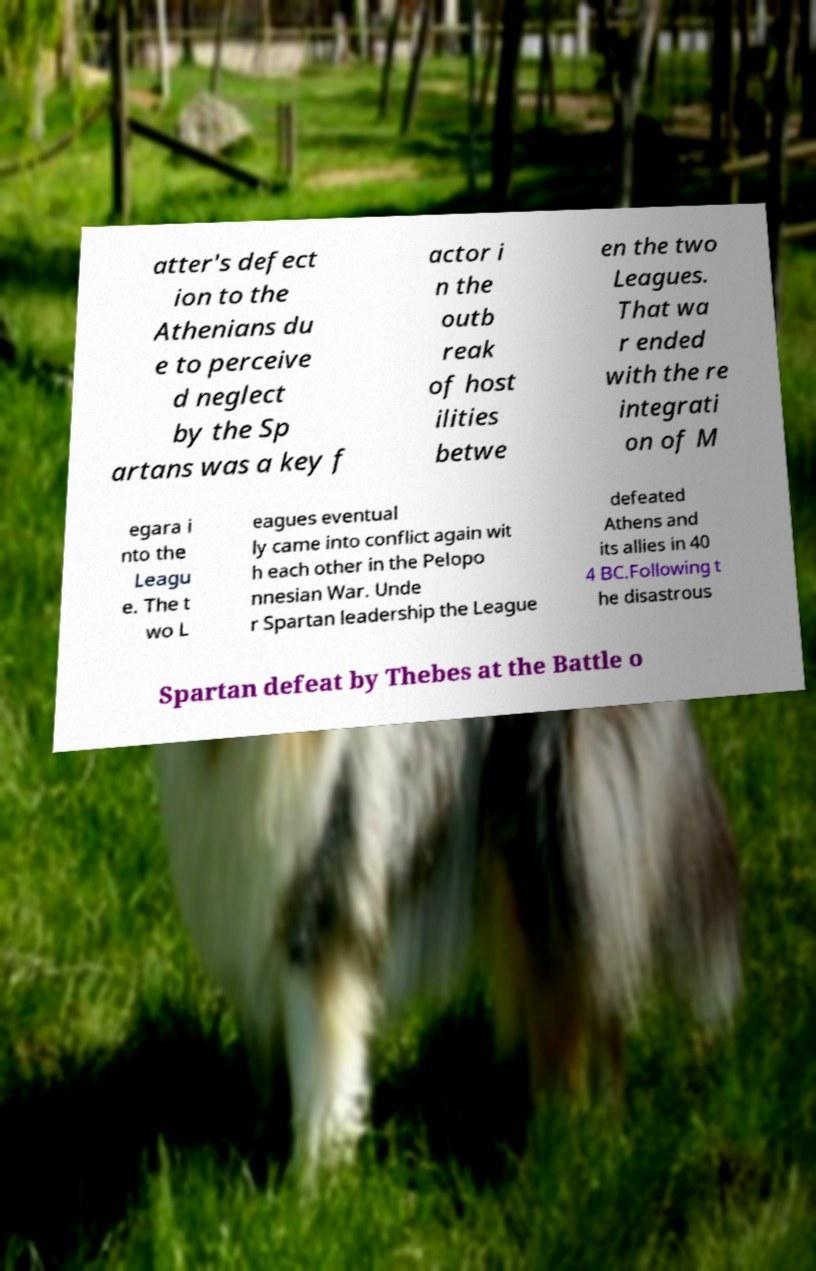Please identify and transcribe the text found in this image. atter's defect ion to the Athenians du e to perceive d neglect by the Sp artans was a key f actor i n the outb reak of host ilities betwe en the two Leagues. That wa r ended with the re integrati on of M egara i nto the Leagu e. The t wo L eagues eventual ly came into conflict again wit h each other in the Pelopo nnesian War. Unde r Spartan leadership the League defeated Athens and its allies in 40 4 BC.Following t he disastrous Spartan defeat by Thebes at the Battle o 